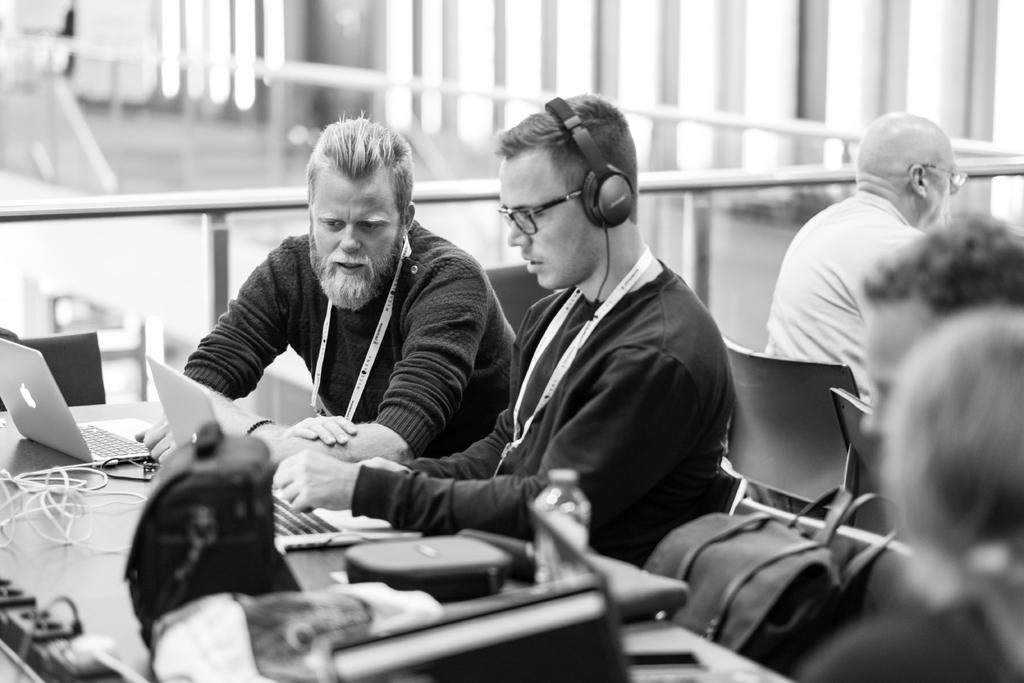What are the people in the image doing? The people in the image are sitting. What objects can be seen on the table in the image? There are laptops and a water bottle on the table in the image. Can you see any cheese being shared between the people in the image? There is no cheese present in the image. 